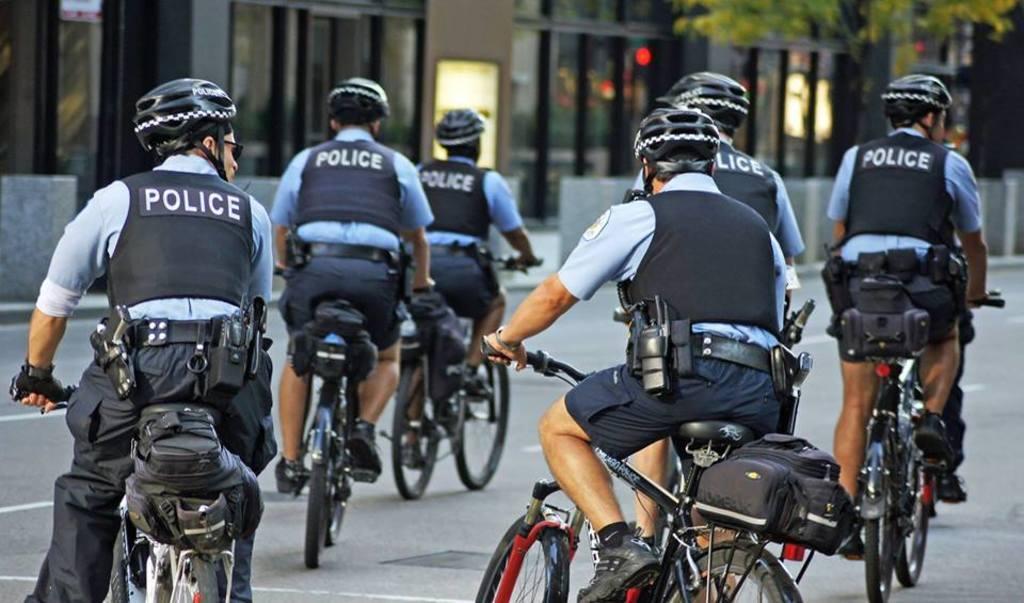Could you give a brief overview of what you see in this image? In the image we can see there are people who are sitting on bicycle and the bicycle is on the road. 